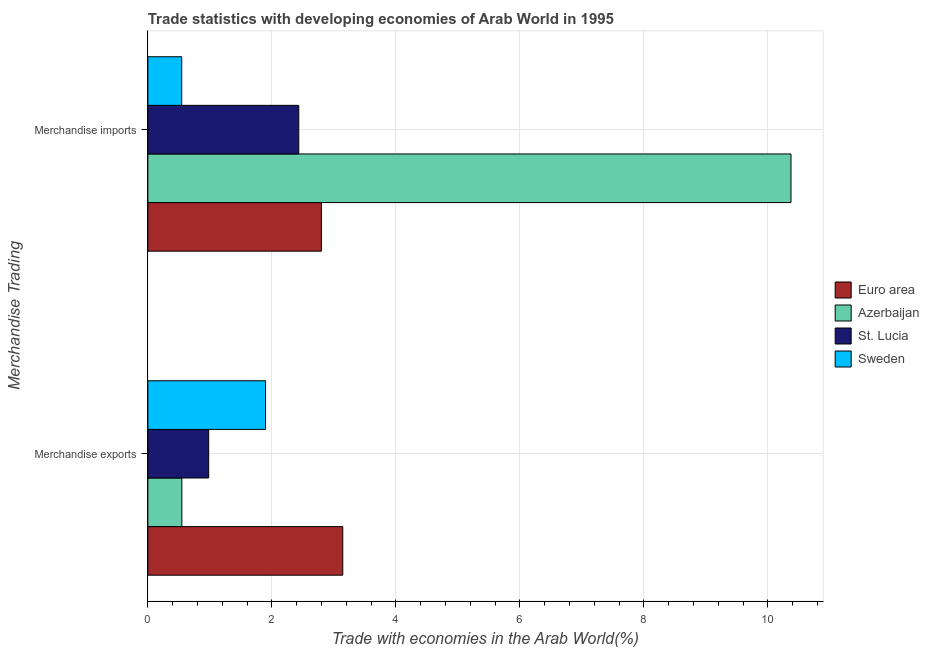How many different coloured bars are there?
Your answer should be compact. 4. Are the number of bars per tick equal to the number of legend labels?
Make the answer very short. Yes. What is the merchandise exports in Euro area?
Ensure brevity in your answer.  3.14. Across all countries, what is the maximum merchandise exports?
Provide a succinct answer. 3.14. Across all countries, what is the minimum merchandise exports?
Give a very brief answer. 0.55. What is the total merchandise imports in the graph?
Offer a very short reply. 16.15. What is the difference between the merchandise exports in St. Lucia and that in Euro area?
Offer a terse response. -2.16. What is the difference between the merchandise exports in Sweden and the merchandise imports in St. Lucia?
Your answer should be very brief. -0.54. What is the average merchandise imports per country?
Give a very brief answer. 4.04. What is the difference between the merchandise exports and merchandise imports in Sweden?
Your response must be concise. 1.35. In how many countries, is the merchandise imports greater than 2.8 %?
Keep it short and to the point. 1. What is the ratio of the merchandise imports in Sweden to that in St. Lucia?
Provide a short and direct response. 0.22. In how many countries, is the merchandise exports greater than the average merchandise exports taken over all countries?
Ensure brevity in your answer.  2. What does the 3rd bar from the top in Merchandise imports represents?
Your response must be concise. Azerbaijan. What does the 1st bar from the bottom in Merchandise imports represents?
Give a very brief answer. Euro area. How many bars are there?
Make the answer very short. 8. How many countries are there in the graph?
Provide a succinct answer. 4. What is the difference between two consecutive major ticks on the X-axis?
Make the answer very short. 2. Are the values on the major ticks of X-axis written in scientific E-notation?
Provide a succinct answer. No. Does the graph contain any zero values?
Your answer should be compact. No. Does the graph contain grids?
Your answer should be compact. Yes. How are the legend labels stacked?
Provide a succinct answer. Vertical. What is the title of the graph?
Your answer should be compact. Trade statistics with developing economies of Arab World in 1995. What is the label or title of the X-axis?
Your answer should be compact. Trade with economies in the Arab World(%). What is the label or title of the Y-axis?
Give a very brief answer. Merchandise Trading. What is the Trade with economies in the Arab World(%) of Euro area in Merchandise exports?
Give a very brief answer. 3.14. What is the Trade with economies in the Arab World(%) in Azerbaijan in Merchandise exports?
Give a very brief answer. 0.55. What is the Trade with economies in the Arab World(%) in St. Lucia in Merchandise exports?
Make the answer very short. 0.98. What is the Trade with economies in the Arab World(%) in Sweden in Merchandise exports?
Your response must be concise. 1.9. What is the Trade with economies in the Arab World(%) in Euro area in Merchandise imports?
Keep it short and to the point. 2.8. What is the Trade with economies in the Arab World(%) of Azerbaijan in Merchandise imports?
Provide a short and direct response. 10.37. What is the Trade with economies in the Arab World(%) of St. Lucia in Merchandise imports?
Provide a short and direct response. 2.43. What is the Trade with economies in the Arab World(%) of Sweden in Merchandise imports?
Offer a very short reply. 0.55. Across all Merchandise Trading, what is the maximum Trade with economies in the Arab World(%) of Euro area?
Give a very brief answer. 3.14. Across all Merchandise Trading, what is the maximum Trade with economies in the Arab World(%) of Azerbaijan?
Your response must be concise. 10.37. Across all Merchandise Trading, what is the maximum Trade with economies in the Arab World(%) in St. Lucia?
Keep it short and to the point. 2.43. Across all Merchandise Trading, what is the maximum Trade with economies in the Arab World(%) of Sweden?
Give a very brief answer. 1.9. Across all Merchandise Trading, what is the minimum Trade with economies in the Arab World(%) of Euro area?
Provide a succinct answer. 2.8. Across all Merchandise Trading, what is the minimum Trade with economies in the Arab World(%) of Azerbaijan?
Your answer should be compact. 0.55. Across all Merchandise Trading, what is the minimum Trade with economies in the Arab World(%) of St. Lucia?
Keep it short and to the point. 0.98. Across all Merchandise Trading, what is the minimum Trade with economies in the Arab World(%) in Sweden?
Ensure brevity in your answer.  0.55. What is the total Trade with economies in the Arab World(%) of Euro area in the graph?
Your response must be concise. 5.94. What is the total Trade with economies in the Arab World(%) in Azerbaijan in the graph?
Ensure brevity in your answer.  10.92. What is the total Trade with economies in the Arab World(%) of St. Lucia in the graph?
Provide a succinct answer. 3.41. What is the total Trade with economies in the Arab World(%) of Sweden in the graph?
Ensure brevity in your answer.  2.44. What is the difference between the Trade with economies in the Arab World(%) in Euro area in Merchandise exports and that in Merchandise imports?
Ensure brevity in your answer.  0.34. What is the difference between the Trade with economies in the Arab World(%) in Azerbaijan in Merchandise exports and that in Merchandise imports?
Your answer should be compact. -9.82. What is the difference between the Trade with economies in the Arab World(%) of St. Lucia in Merchandise exports and that in Merchandise imports?
Keep it short and to the point. -1.45. What is the difference between the Trade with economies in the Arab World(%) in Sweden in Merchandise exports and that in Merchandise imports?
Offer a terse response. 1.35. What is the difference between the Trade with economies in the Arab World(%) of Euro area in Merchandise exports and the Trade with economies in the Arab World(%) of Azerbaijan in Merchandise imports?
Make the answer very short. -7.23. What is the difference between the Trade with economies in the Arab World(%) in Euro area in Merchandise exports and the Trade with economies in the Arab World(%) in St. Lucia in Merchandise imports?
Provide a short and direct response. 0.71. What is the difference between the Trade with economies in the Arab World(%) of Euro area in Merchandise exports and the Trade with economies in the Arab World(%) of Sweden in Merchandise imports?
Your answer should be very brief. 2.6. What is the difference between the Trade with economies in the Arab World(%) of Azerbaijan in Merchandise exports and the Trade with economies in the Arab World(%) of St. Lucia in Merchandise imports?
Your answer should be compact. -1.89. What is the difference between the Trade with economies in the Arab World(%) of Azerbaijan in Merchandise exports and the Trade with economies in the Arab World(%) of Sweden in Merchandise imports?
Provide a succinct answer. 0. What is the difference between the Trade with economies in the Arab World(%) in St. Lucia in Merchandise exports and the Trade with economies in the Arab World(%) in Sweden in Merchandise imports?
Give a very brief answer. 0.43. What is the average Trade with economies in the Arab World(%) in Euro area per Merchandise Trading?
Give a very brief answer. 2.97. What is the average Trade with economies in the Arab World(%) of Azerbaijan per Merchandise Trading?
Offer a terse response. 5.46. What is the average Trade with economies in the Arab World(%) in St. Lucia per Merchandise Trading?
Keep it short and to the point. 1.71. What is the average Trade with economies in the Arab World(%) in Sweden per Merchandise Trading?
Ensure brevity in your answer.  1.22. What is the difference between the Trade with economies in the Arab World(%) in Euro area and Trade with economies in the Arab World(%) in Azerbaijan in Merchandise exports?
Make the answer very short. 2.6. What is the difference between the Trade with economies in the Arab World(%) in Euro area and Trade with economies in the Arab World(%) in St. Lucia in Merchandise exports?
Ensure brevity in your answer.  2.16. What is the difference between the Trade with economies in the Arab World(%) of Euro area and Trade with economies in the Arab World(%) of Sweden in Merchandise exports?
Make the answer very short. 1.25. What is the difference between the Trade with economies in the Arab World(%) in Azerbaijan and Trade with economies in the Arab World(%) in St. Lucia in Merchandise exports?
Your answer should be very brief. -0.43. What is the difference between the Trade with economies in the Arab World(%) of Azerbaijan and Trade with economies in the Arab World(%) of Sweden in Merchandise exports?
Offer a very short reply. -1.35. What is the difference between the Trade with economies in the Arab World(%) of St. Lucia and Trade with economies in the Arab World(%) of Sweden in Merchandise exports?
Your answer should be compact. -0.92. What is the difference between the Trade with economies in the Arab World(%) of Euro area and Trade with economies in the Arab World(%) of Azerbaijan in Merchandise imports?
Ensure brevity in your answer.  -7.57. What is the difference between the Trade with economies in the Arab World(%) of Euro area and Trade with economies in the Arab World(%) of St. Lucia in Merchandise imports?
Your answer should be compact. 0.37. What is the difference between the Trade with economies in the Arab World(%) of Euro area and Trade with economies in the Arab World(%) of Sweden in Merchandise imports?
Your answer should be compact. 2.25. What is the difference between the Trade with economies in the Arab World(%) in Azerbaijan and Trade with economies in the Arab World(%) in St. Lucia in Merchandise imports?
Provide a short and direct response. 7.94. What is the difference between the Trade with economies in the Arab World(%) in Azerbaijan and Trade with economies in the Arab World(%) in Sweden in Merchandise imports?
Make the answer very short. 9.83. What is the difference between the Trade with economies in the Arab World(%) in St. Lucia and Trade with economies in the Arab World(%) in Sweden in Merchandise imports?
Keep it short and to the point. 1.89. What is the ratio of the Trade with economies in the Arab World(%) of Euro area in Merchandise exports to that in Merchandise imports?
Make the answer very short. 1.12. What is the ratio of the Trade with economies in the Arab World(%) in Azerbaijan in Merchandise exports to that in Merchandise imports?
Provide a succinct answer. 0.05. What is the ratio of the Trade with economies in the Arab World(%) in St. Lucia in Merchandise exports to that in Merchandise imports?
Make the answer very short. 0.4. What is the ratio of the Trade with economies in the Arab World(%) in Sweden in Merchandise exports to that in Merchandise imports?
Give a very brief answer. 3.48. What is the difference between the highest and the second highest Trade with economies in the Arab World(%) of Euro area?
Keep it short and to the point. 0.34. What is the difference between the highest and the second highest Trade with economies in the Arab World(%) in Azerbaijan?
Provide a short and direct response. 9.82. What is the difference between the highest and the second highest Trade with economies in the Arab World(%) in St. Lucia?
Give a very brief answer. 1.45. What is the difference between the highest and the second highest Trade with economies in the Arab World(%) in Sweden?
Keep it short and to the point. 1.35. What is the difference between the highest and the lowest Trade with economies in the Arab World(%) of Euro area?
Provide a succinct answer. 0.34. What is the difference between the highest and the lowest Trade with economies in the Arab World(%) of Azerbaijan?
Keep it short and to the point. 9.82. What is the difference between the highest and the lowest Trade with economies in the Arab World(%) of St. Lucia?
Keep it short and to the point. 1.45. What is the difference between the highest and the lowest Trade with economies in the Arab World(%) in Sweden?
Ensure brevity in your answer.  1.35. 